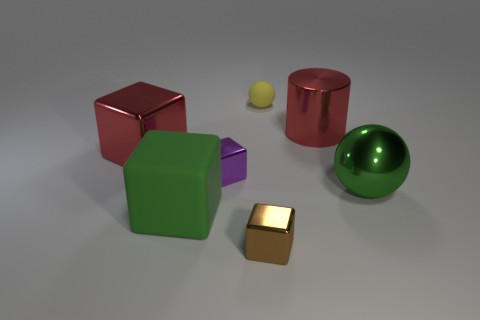Add 2 purple metal blocks. How many objects exist? 9 Subtract all purple cubes. How many cubes are left? 3 Subtract all red blocks. How many blocks are left? 3 Subtract 1 cylinders. How many cylinders are left? 0 Subtract all balls. How many objects are left? 5 Subtract all red blocks. How many green spheres are left? 1 Add 6 red metal cylinders. How many red metal cylinders exist? 7 Subtract 0 cyan blocks. How many objects are left? 7 Subtract all cyan cylinders. Subtract all brown balls. How many cylinders are left? 1 Subtract all large yellow rubber cylinders. Subtract all green things. How many objects are left? 5 